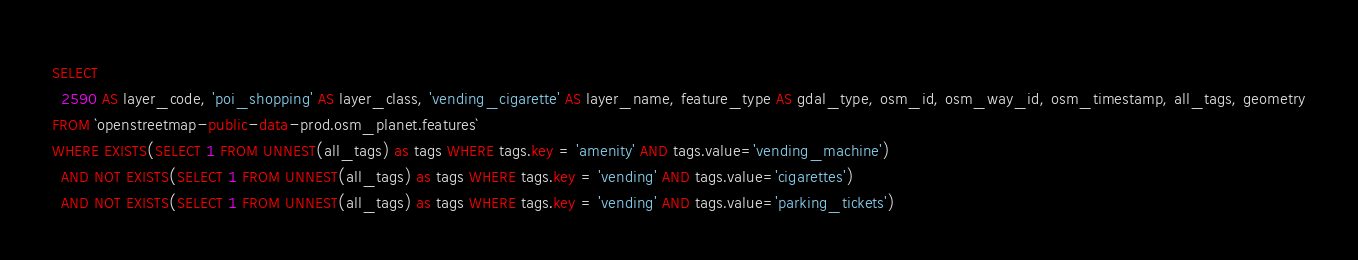<code> <loc_0><loc_0><loc_500><loc_500><_SQL_>SELECT
  2590 AS layer_code, 'poi_shopping' AS layer_class, 'vending_cigarette' AS layer_name, feature_type AS gdal_type, osm_id, osm_way_id, osm_timestamp, all_tags, geometry
FROM `openstreetmap-public-data-prod.osm_planet.features`
WHERE EXISTS(SELECT 1 FROM UNNEST(all_tags) as tags WHERE tags.key = 'amenity' AND tags.value='vending_machine')
  AND NOT EXISTS(SELECT 1 FROM UNNEST(all_tags) as tags WHERE tags.key = 'vending' AND tags.value='cigarettes')
  AND NOT EXISTS(SELECT 1 FROM UNNEST(all_tags) as tags WHERE tags.key = 'vending' AND tags.value='parking_tickets')
</code> 